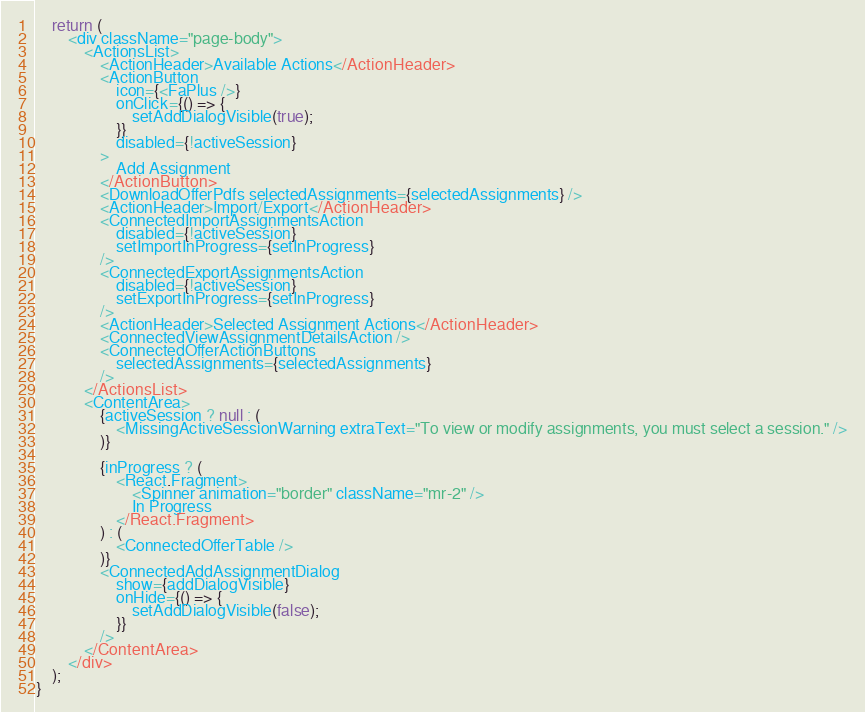<code> <loc_0><loc_0><loc_500><loc_500><_TypeScript_>    return (
        <div className="page-body">
            <ActionsList>
                <ActionHeader>Available Actions</ActionHeader>
                <ActionButton
                    icon={<FaPlus />}
                    onClick={() => {
                        setAddDialogVisible(true);
                    }}
                    disabled={!activeSession}
                >
                    Add Assignment
                </ActionButton>
                <DownloadOfferPdfs selectedAssignments={selectedAssignments} />
                <ActionHeader>Import/Export</ActionHeader>
                <ConnectedImportAssignmentsAction
                    disabled={!activeSession}
                    setImportInProgress={setInProgress}
                />
                <ConnectedExportAssignmentsAction
                    disabled={!activeSession}
                    setExportInProgress={setInProgress}
                />
                <ActionHeader>Selected Assignment Actions</ActionHeader>
                <ConnectedViewAssignmentDetailsAction />
                <ConnectedOfferActionButtons
                    selectedAssignments={selectedAssignments}
                />
            </ActionsList>
            <ContentArea>
                {activeSession ? null : (
                    <MissingActiveSessionWarning extraText="To view or modify assignments, you must select a session." />
                )}

                {inProgress ? (
                    <React.Fragment>
                        <Spinner animation="border" className="mr-2" />
                        In Progress
                    </React.Fragment>
                ) : (
                    <ConnectedOfferTable />
                )}
                <ConnectedAddAssignmentDialog
                    show={addDialogVisible}
                    onHide={() => {
                        setAddDialogVisible(false);
                    }}
                />
            </ContentArea>
        </div>
    );
}
</code> 